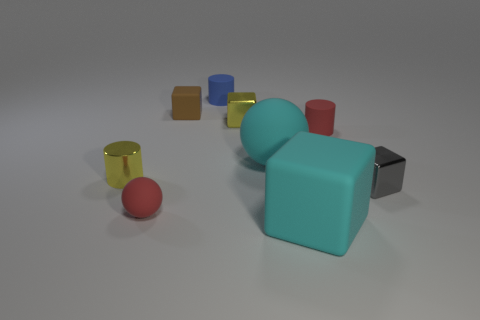What materials are represented by the objects in the image? The objects in the image seem to be made of two different types of materials. The cylinders and cubes exhibit a reflective, shiny surface suggesting they could be made of a polished metal or plastic, while the sphere has a matte finish indicating it may be made of a different material, possibly a rubber or a non-reflective plastic. 